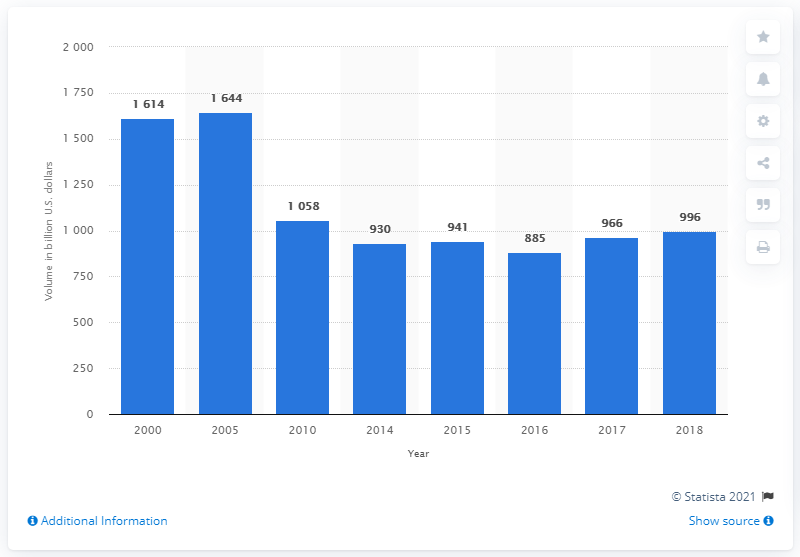Can you describe the significance of the changes in money market volume shown in the chart? The changes in money market volumes can reflect a variety of economic conditions. A peak often suggests increased use of money markets for liquidity and short-term financing. The post-2005 decline may be due to market corrections, changes in regulations, or shifts in investor preferences. The stabilization after 2010 could indicate a new equilibrium in the demand for money market instruments as markets adjusted to the post-financial crisis environment. 